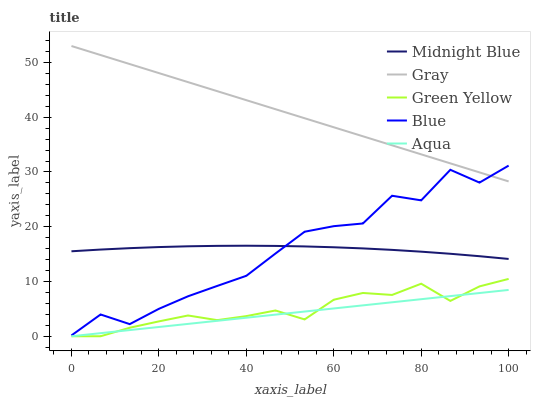Does Aqua have the minimum area under the curve?
Answer yes or no. Yes. Does Gray have the maximum area under the curve?
Answer yes or no. Yes. Does Green Yellow have the minimum area under the curve?
Answer yes or no. No. Does Green Yellow have the maximum area under the curve?
Answer yes or no. No. Is Aqua the smoothest?
Answer yes or no. Yes. Is Blue the roughest?
Answer yes or no. Yes. Is Gray the smoothest?
Answer yes or no. No. Is Gray the roughest?
Answer yes or no. No. Does Green Yellow have the lowest value?
Answer yes or no. Yes. Does Gray have the lowest value?
Answer yes or no. No. Does Gray have the highest value?
Answer yes or no. Yes. Does Green Yellow have the highest value?
Answer yes or no. No. Is Green Yellow less than Midnight Blue?
Answer yes or no. Yes. Is Blue greater than Aqua?
Answer yes or no. Yes. Does Blue intersect Midnight Blue?
Answer yes or no. Yes. Is Blue less than Midnight Blue?
Answer yes or no. No. Is Blue greater than Midnight Blue?
Answer yes or no. No. Does Green Yellow intersect Midnight Blue?
Answer yes or no. No. 